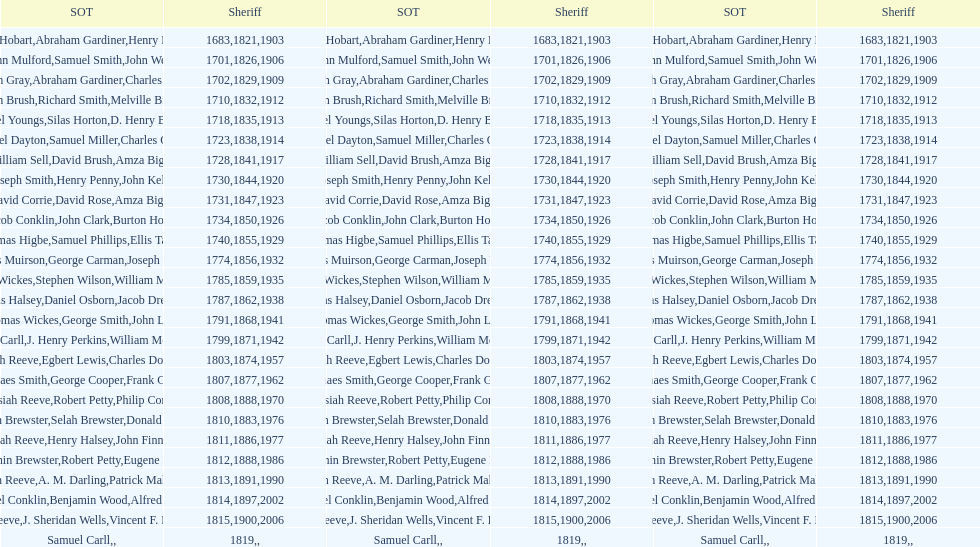What is the total number of sheriffs that were in office in suffolk county between 1903 and 1957? 17. 